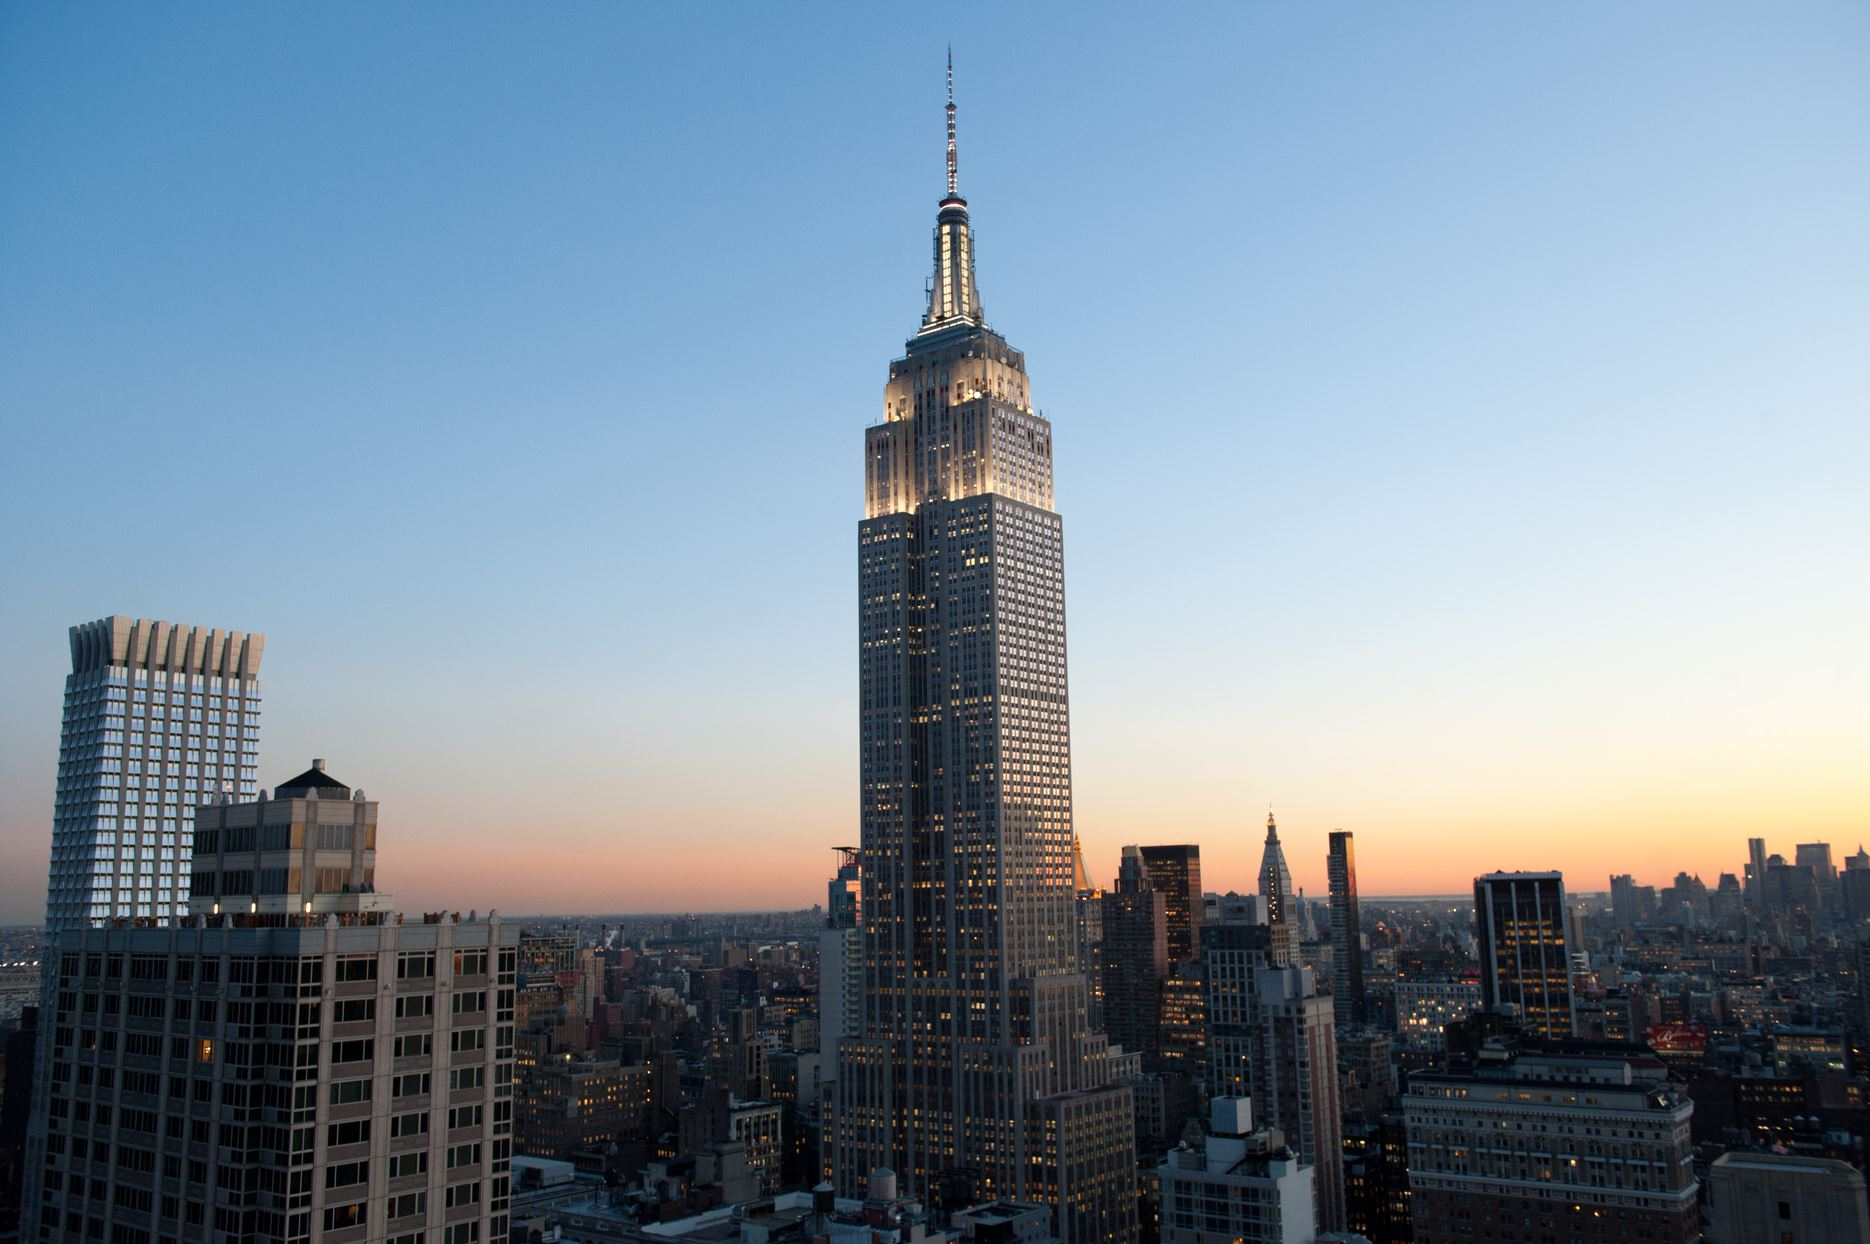Write a detailed description of the given image. The image captures a breathtaking view of the Empire State Building in New York City during the twilight hours. This iconic skyscraper stands as a beacon, lit brilliantly against the fading light of the day. The building's art deco architecture, characterized by its symmetrical geometric forms, is highlighted by its bright lights. Around it, numerous other buildings form a dense urban tapestry, their windows aglow under a sky painted with a gradient from deep orange to dusky blue. This scene not only showcases the building's imposing stature but also its role as a central figure in the city's vibrant life. 